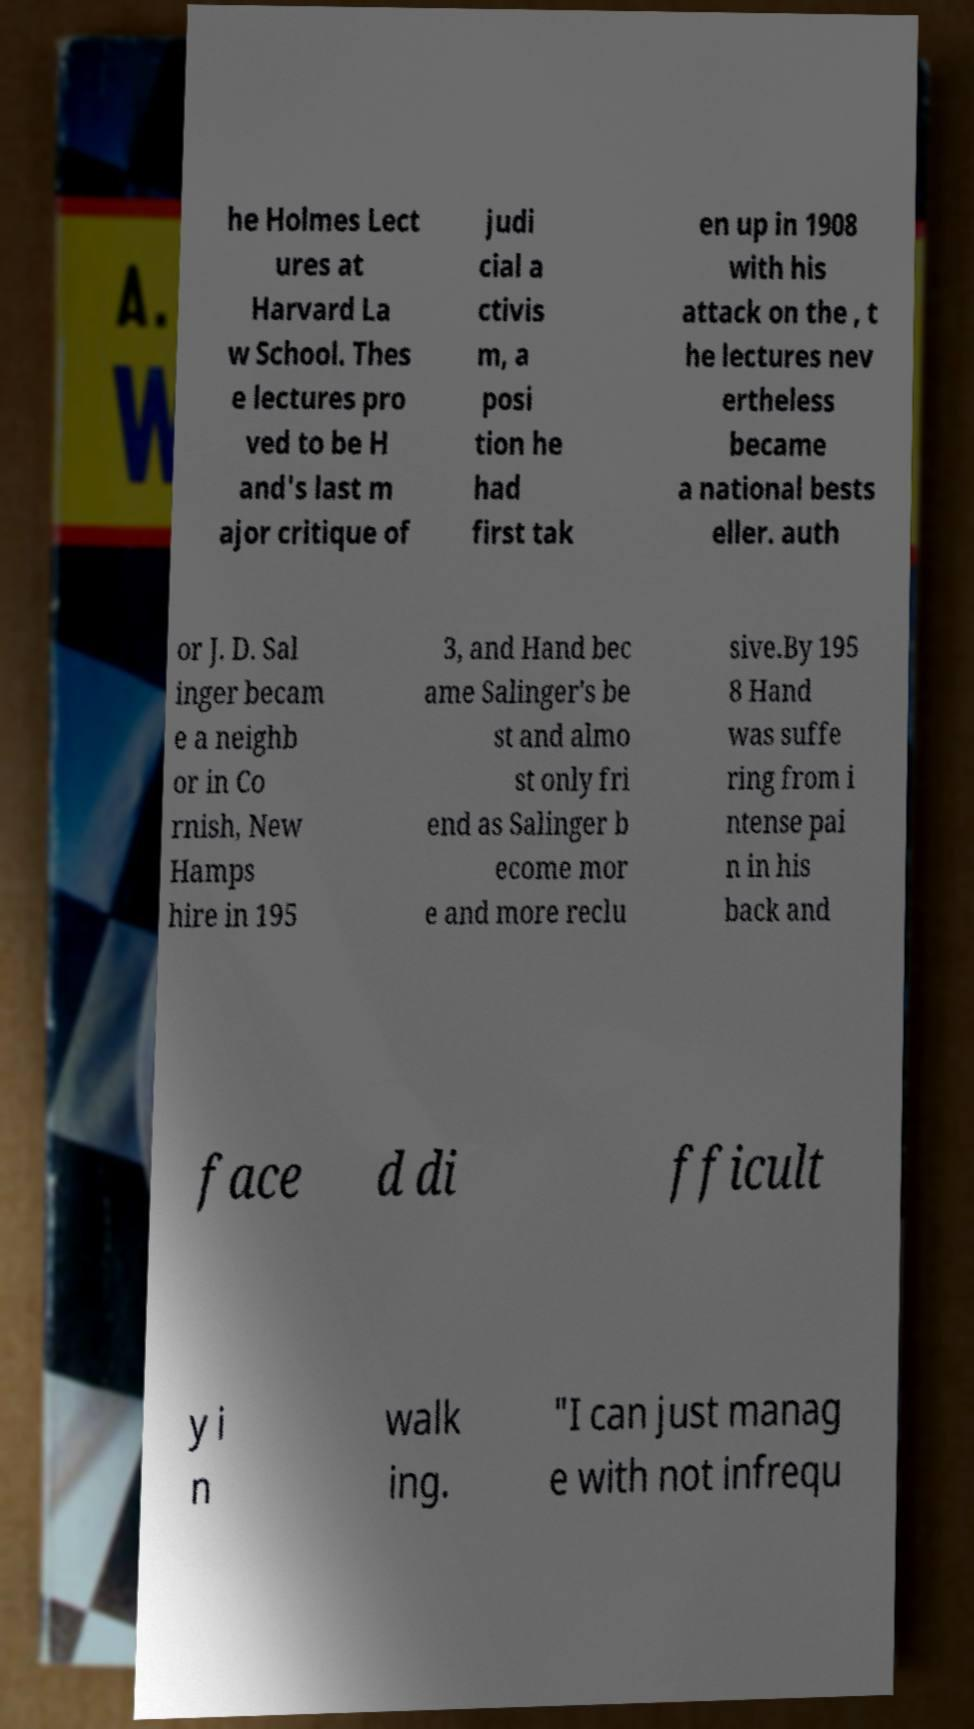Can you accurately transcribe the text from the provided image for me? he Holmes Lect ures at Harvard La w School. Thes e lectures pro ved to be H and's last m ajor critique of judi cial a ctivis m, a posi tion he had first tak en up in 1908 with his attack on the , t he lectures nev ertheless became a national bests eller. auth or J. D. Sal inger becam e a neighb or in Co rnish, New Hamps hire in 195 3, and Hand bec ame Salinger's be st and almo st only fri end as Salinger b ecome mor e and more reclu sive.By 195 8 Hand was suffe ring from i ntense pai n in his back and face d di fficult y i n walk ing. "I can just manag e with not infrequ 